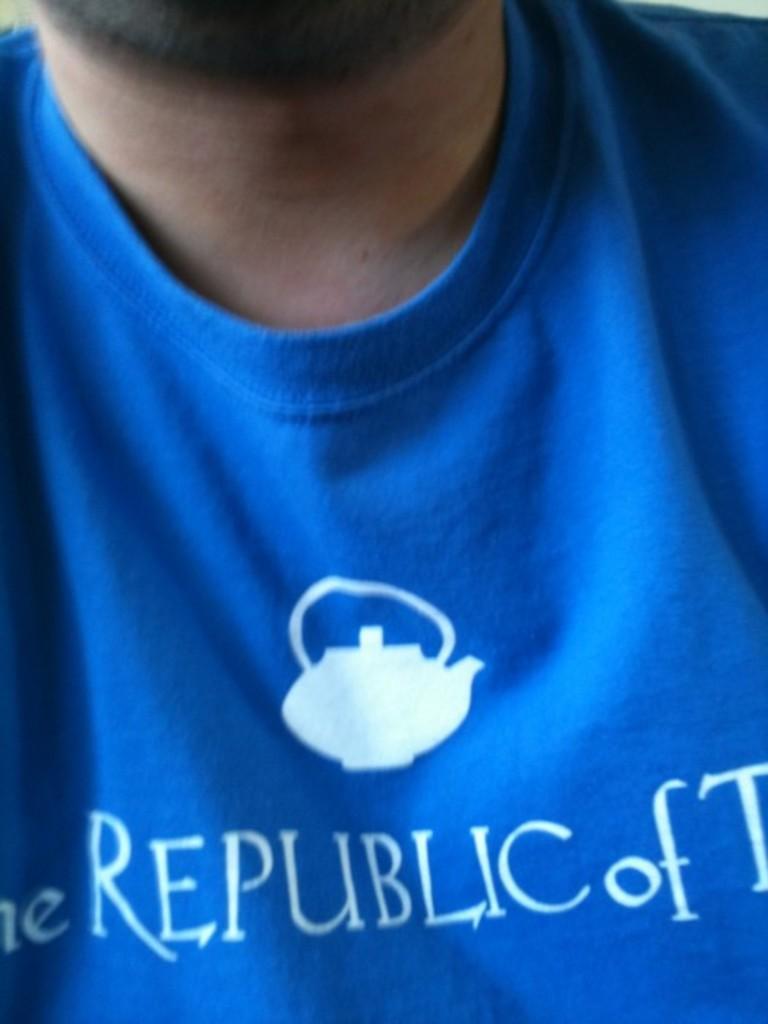In one or two sentences, can you explain what this image depicts? In this picture we can see a person wearing a blue t-shirt, on the t-shirt there is some text. 